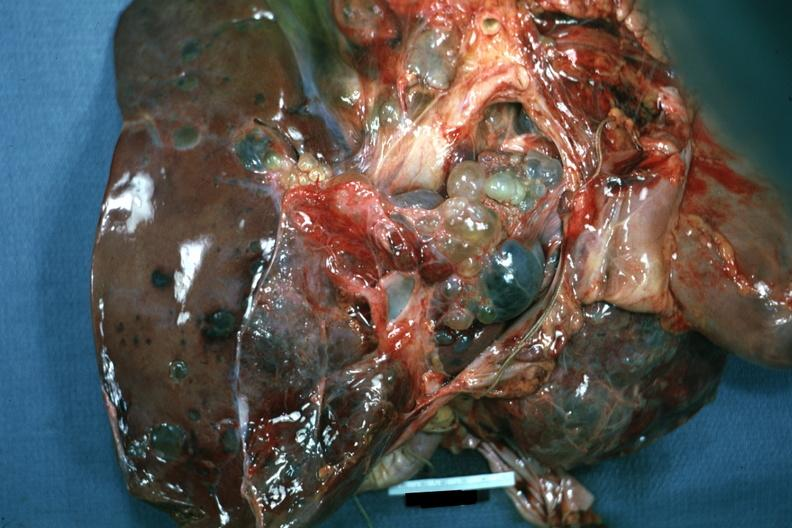what seen from external?
Answer the question using a single word or phrase. Case of polycystic disease lesions 